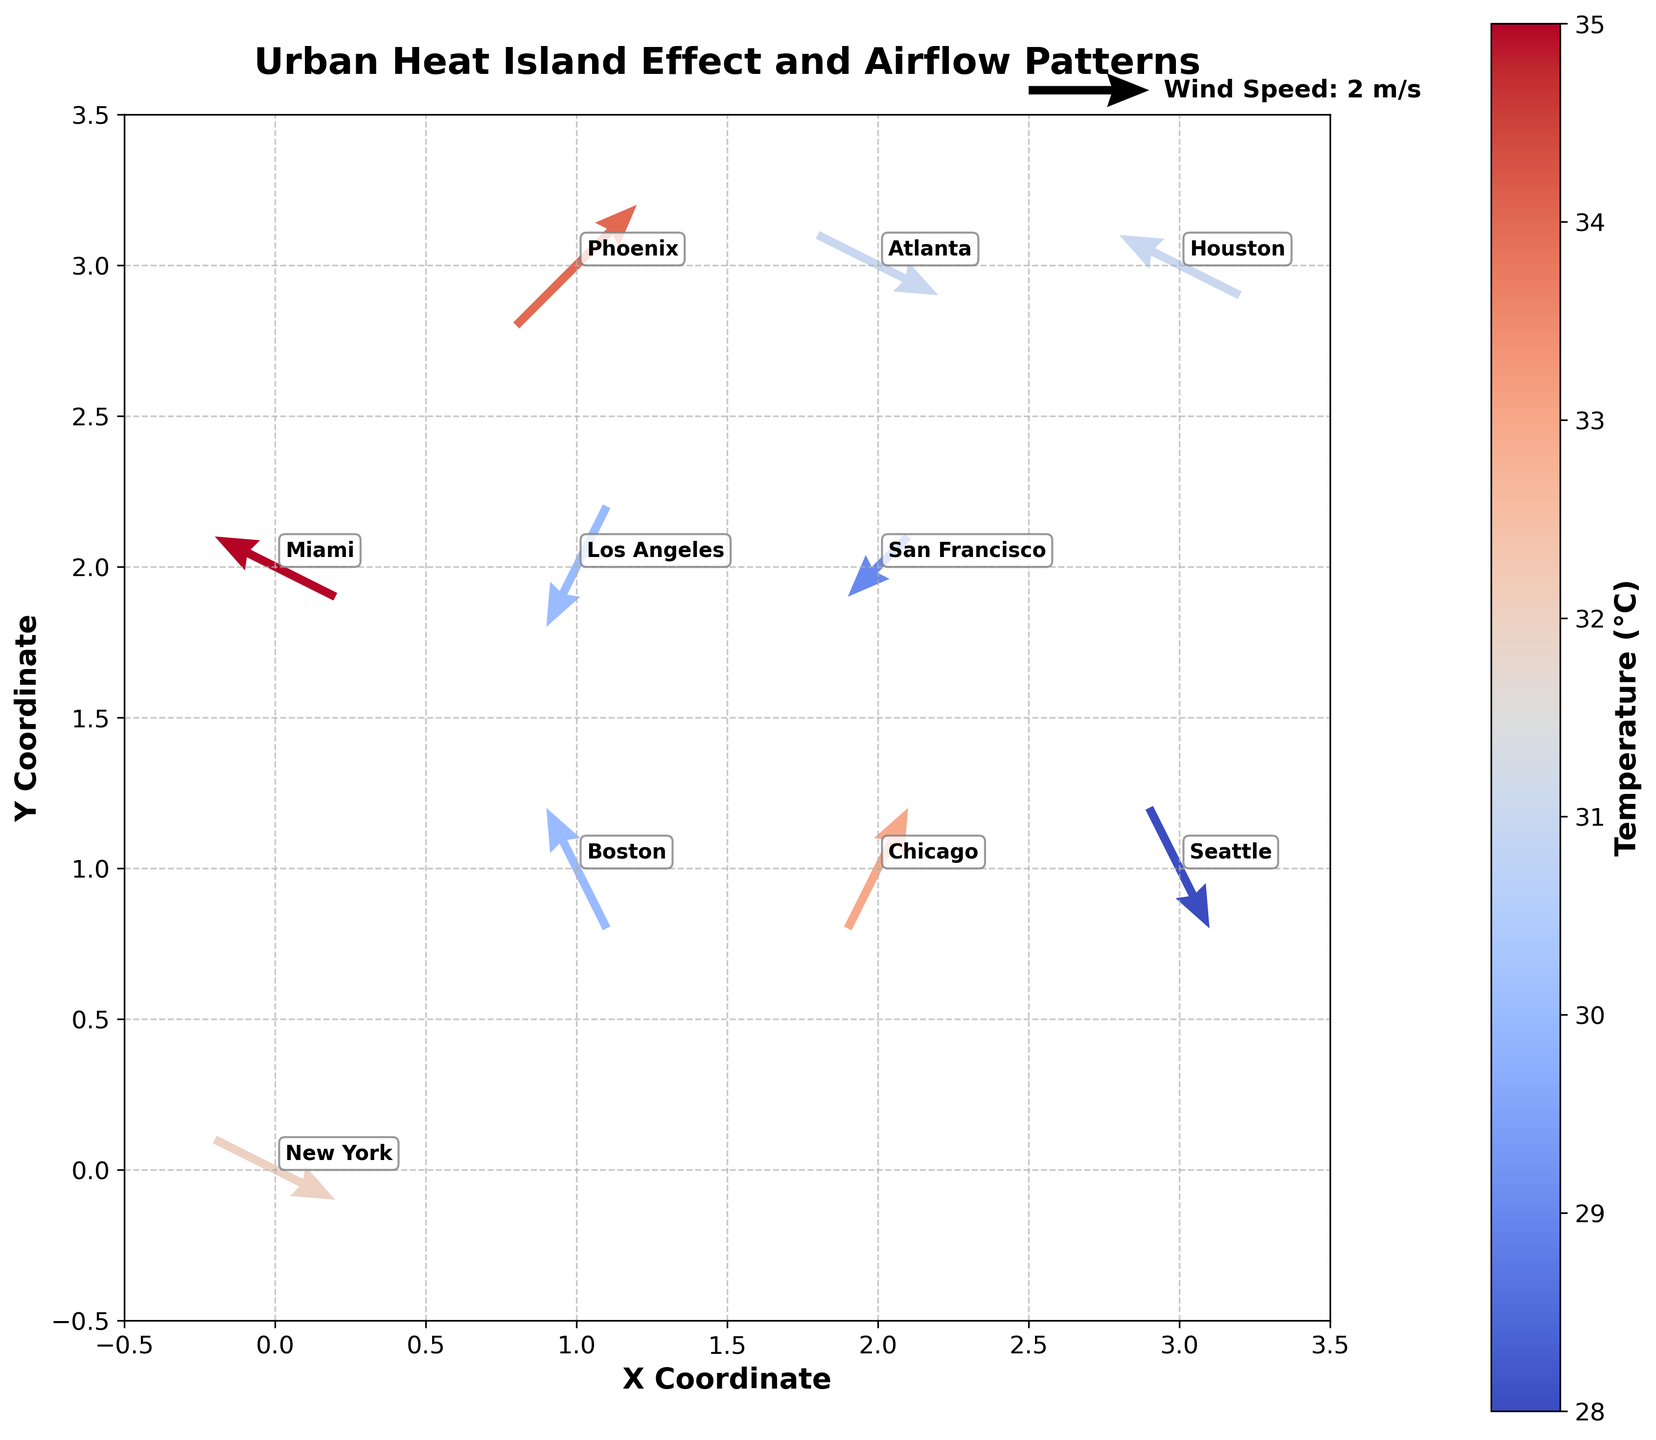What is the title of the plot? The title is usually displayed at the top of the figure in larger, bold font. For this plot, the title reads "Urban Heat Island Effect and Airflow Patterns".
Answer: Urban Heat Island Effect and Airflow Patterns Which city has the highest temperature? To find the highest temperature, you need to look at the color gradient annotated by the color bar and identify the city corresponding to the warmest color. Miami appears to have the highest temperature at 35°C.
Answer: Miami Which cities have airflow vectors pointing directly north? Vectors pointing north have positive values in the \( v \) direction and zero in the \( u \) direction. Referring to the quiver plot, Boston and Chicago have vectors pointing north.
Answer: Boston and Chicago How many data points are represented in the plot? Each data point in the plot corresponds to a pair of arrows and a city label. By counting all the cities in the plot, you can determine there are 10 data points.
Answer: 10 Among Chicago and Houston, which city has a higher temperature, and by how much? Compare the temperatures directly annotated for both cities: Chicago (33°C) and Houston (31°C). The difference is 33 - 31 = 2°C.
Answer: Chicago, by 2°C What are the maximum and minimum \( x \) coordinates in the plot? Review the \( x \) coordinates shown along the x-axis of the plot. The values span from 0 to 3.
Answer: Maximum: 3, Minimum: 0 Which city has the vector with the largest magnitude and what is its magnitude? Calculate the magnitude of each vector using \( \sqrt{u^2 + v^2} \) and compare. Phoenix has (u=2, v=2), magnitude = \( \sqrt{2^2 + 2^2} = \sqrt{8} \approx 2.83 \), which is the largest.
Answer: Phoenix, approximately 2.83 Which cities have a temperature lower than 30°C? Refer to the temperature values annotated for each city. San Francisco (29°C) and Seattle (28°C) have temperatures below 30°C.
Answer: San Francisco and Seattle What direction does the airflow vector in Atlanta point to? The vector's direction can be determined by its components (u=2, v=-1). This indicates a northeast direction, slightly to the east.
Answer: Northeast Compare the airflow patterns in New York and Los Angeles. Which city has a stronger wind speed? Calculate the magnitude for both cities: New York (\( \sqrt{2^2 + (-1)^2} = \sqrt{5} \approx 2.24 \)) and Los Angeles (\( \sqrt{(-1)^2 + (-2)^2} = \sqrt{5} \approx 2.24 \)). Both have equal magnitudes.
Answer: Both have equal magnitudes 